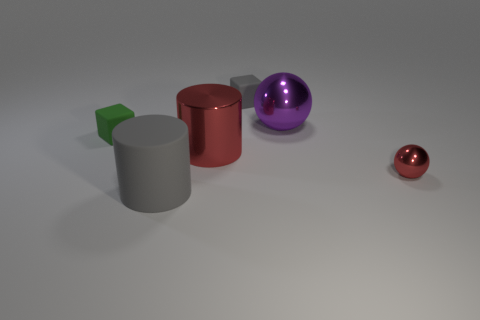Add 4 small shiny things. How many objects exist? 10 Subtract all balls. How many objects are left? 4 Subtract 0 gray balls. How many objects are left? 6 Subtract all small yellow matte cubes. Subtract all small red objects. How many objects are left? 5 Add 4 gray cylinders. How many gray cylinders are left? 5 Add 2 large gray objects. How many large gray objects exist? 3 